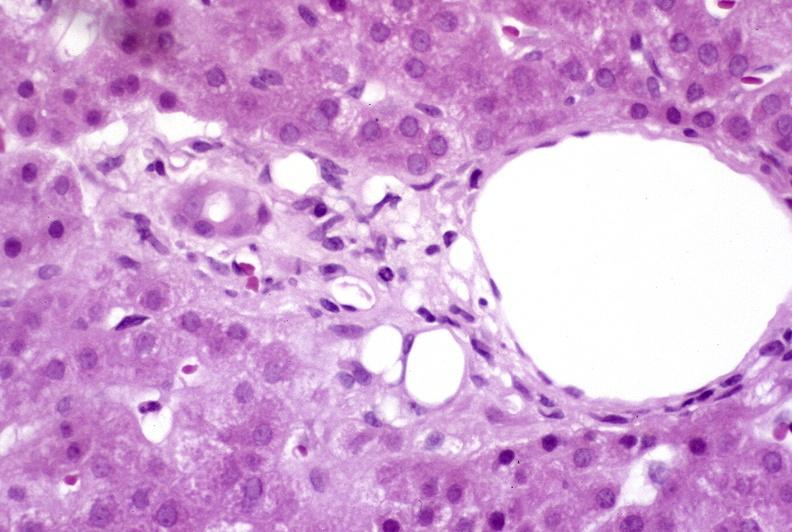does metastatic pancreas carcinoma show recovery of ducts?
Answer the question using a single word or phrase. No 